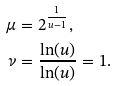<formula> <loc_0><loc_0><loc_500><loc_500>\mu & = 2 ^ { \frac { 1 } { u - 1 } } , \\ \nu & = \frac { \ln ( u ) } { \ln ( u ) } = 1 .</formula> 